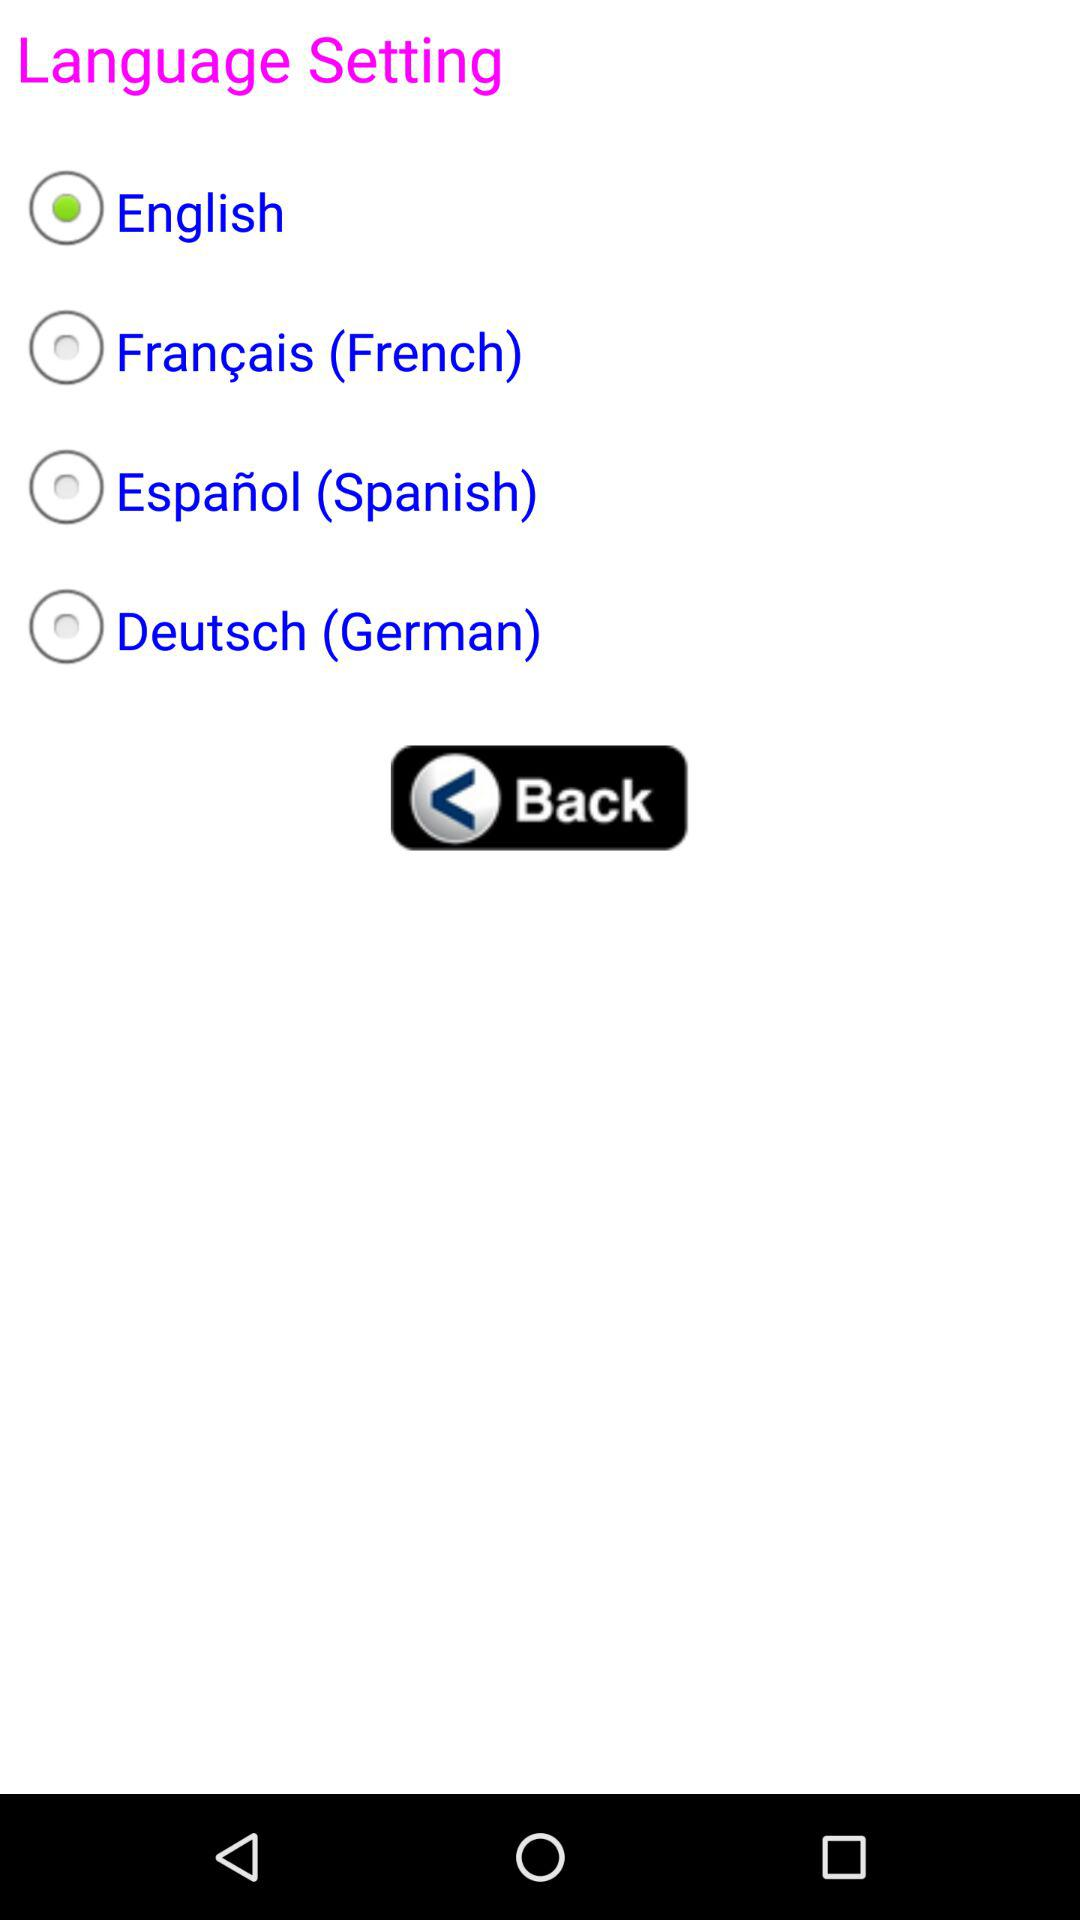How many languages are available to choose from?
Answer the question using a single word or phrase. 4 